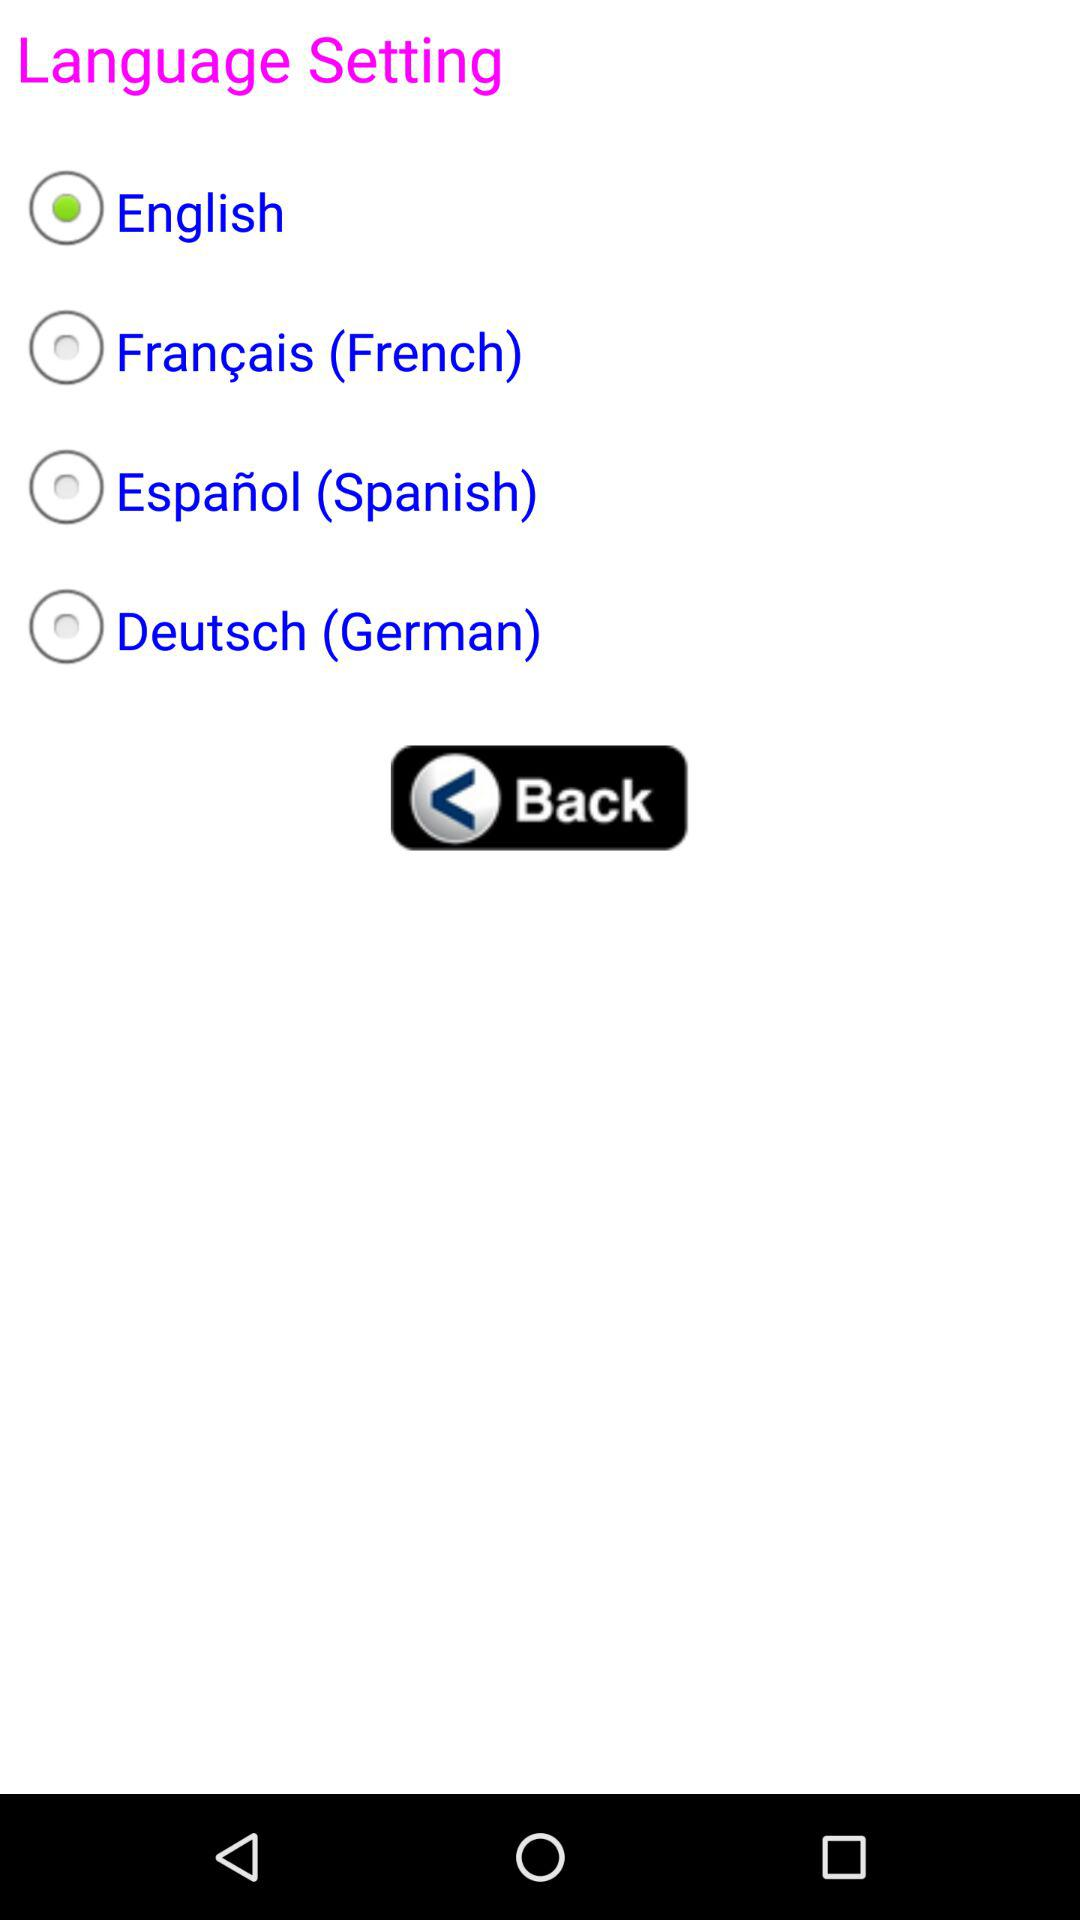How many languages are available to choose from?
Answer the question using a single word or phrase. 4 